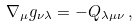Convert formula to latex. <formula><loc_0><loc_0><loc_500><loc_500>\nabla _ { \mu } g _ { \nu \lambda } = - Q _ { \lambda \mu \nu } \, ,</formula> 